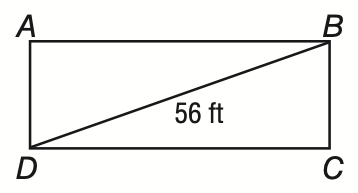Question: The diagonals of rectangle A B C D the have a length of 56 feet. If m \angle B A C = 42, what is the length of A B to the nearest tenth of a foot?
Choices:
A. 41.6
B. 50.4
C. 56.3
D. 75.4
Answer with the letter. Answer: A 